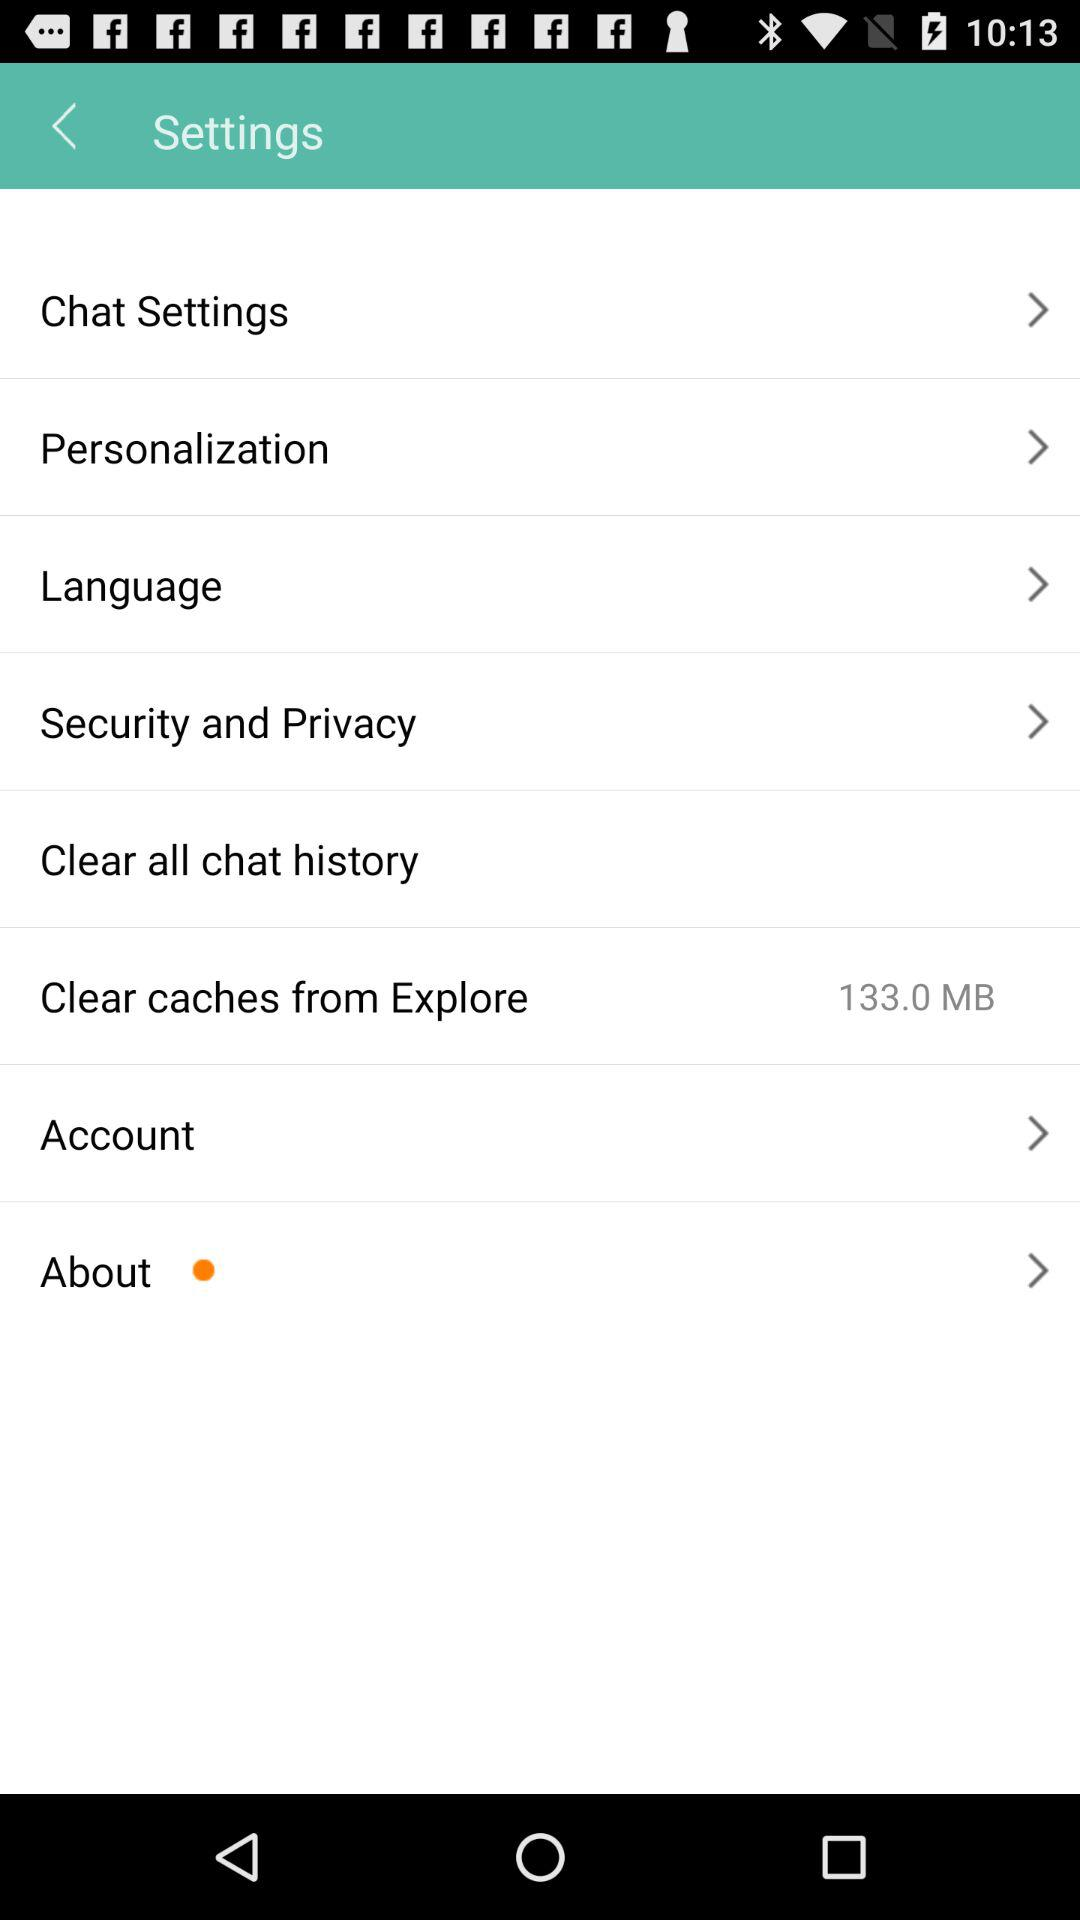How much space is being used by the caches from Explore?
Answer the question using a single word or phrase. 133.0 MB 